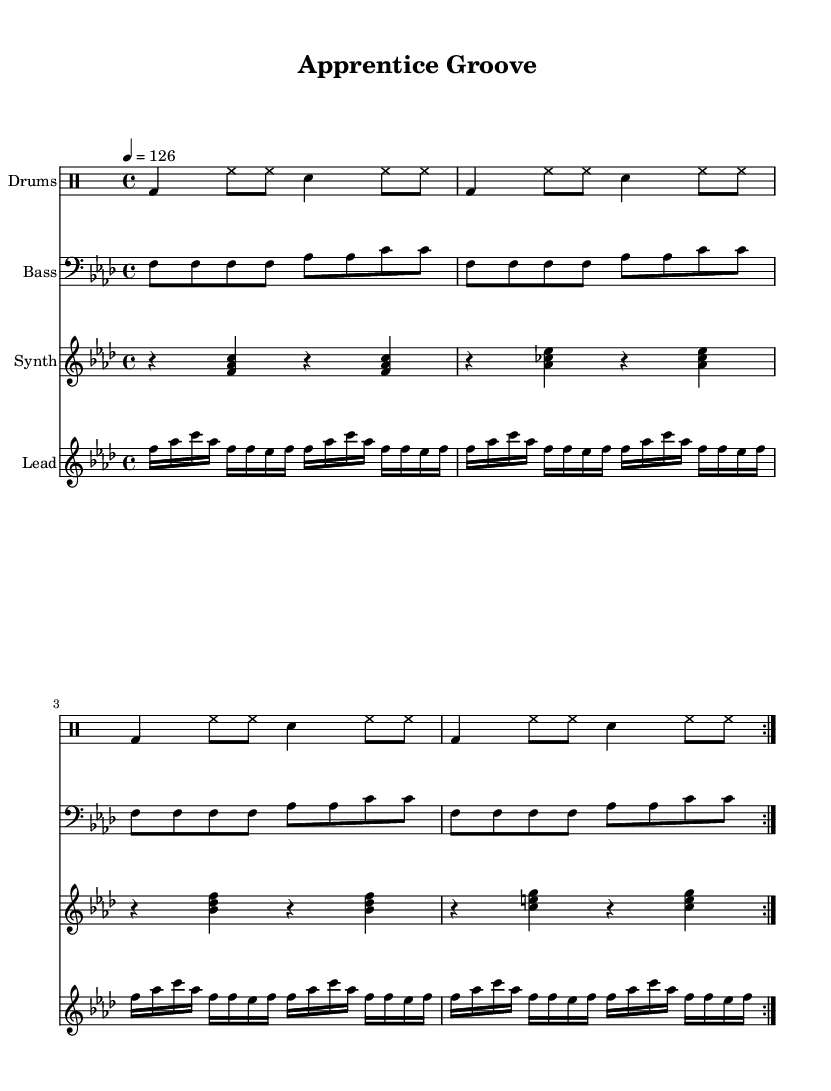What is the key signature of this music? The key signature is F minor, which has four flats (B, E, A, D). This can be identified from the key signature at the beginning of the sheet music where the flat symbols are shown, indicating F minor.
Answer: F minor What is the time signature of this music? The time signature is 4/4, indicated at the beginning of the staff. This means there are four beats per measure, and the quarter note gets one beat. This is a common time signature in house music.
Answer: 4/4 What is the tempo marking of this piece? The tempo marking is 126 beats per minute, indicated by "4 = 126". This suggests a moderately fast pace, typical for energetic house music tracks.
Answer: 126 How many measures repeat in the drums part? The drums part repeats for a total of two measures, indicated by the "repeat volta 2" directive. This tells us that the pattern is played twice for consistency in the rhythm.
Answer: 2 What notes are played in the lead synth part? The lead synth part consists primarily of the notes F, A flat, C, and E flat, as seen in the notes consistently played throughout the section. This pattern contributes to the melodic structure of the piece.
Answer: F, A flat, C, E flat What type of instrumentation is used in the score? The instrumentation includes drums, bass, synth, and lead synthesizer. This diverse blend of instruments is typical for house music, helping to create a rich and layered sound.
Answer: Drums, bass, synth, lead synthesizer What is the rhythm style used in the drums part? The rhythm style combines kick drums, hi-hats, and snares, creating a consistent and driving beat that is characteristic of house music. This can be seen in the specific notation of the drum patterns.
Answer: Kick, hi-hat, snare 